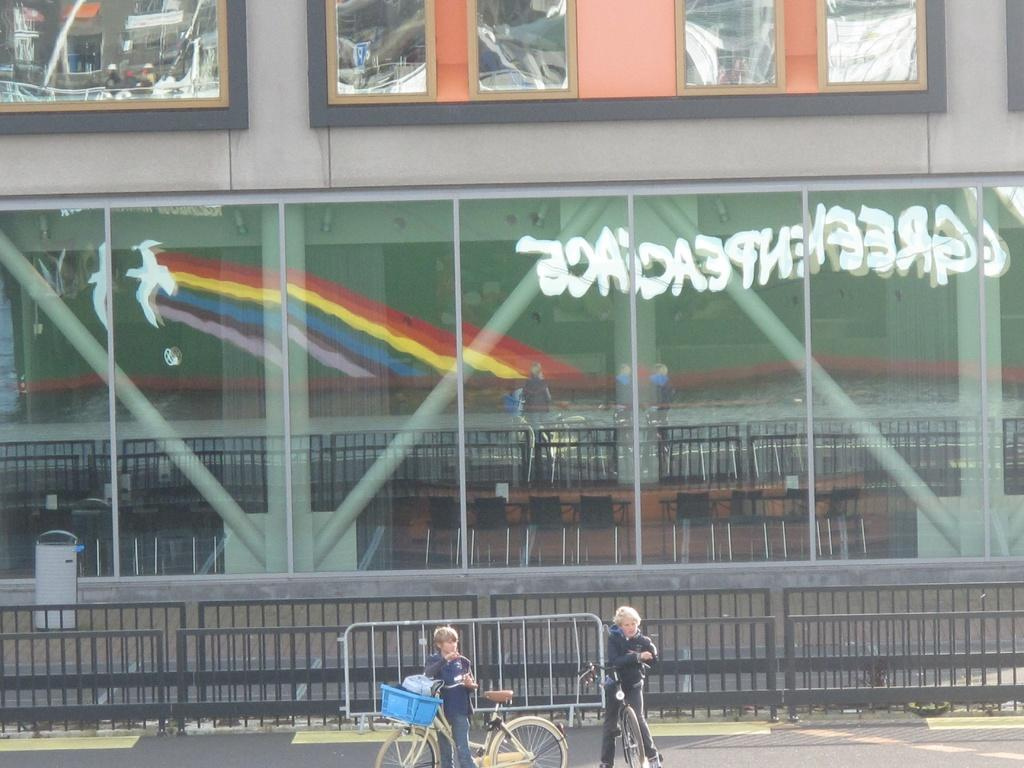<image>
Give a short and clear explanation of the subsequent image. two kids on bikes in front of building with reflection of a Greenpeace signe 